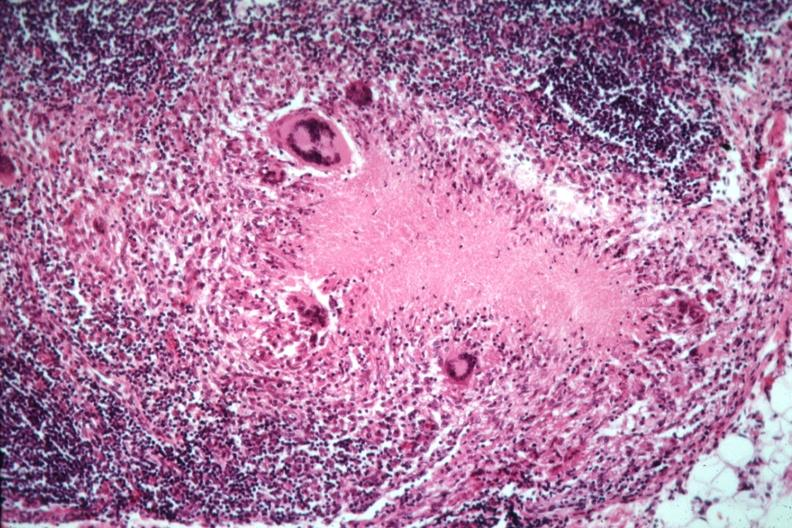s lymph node present?
Answer the question using a single word or phrase. Yes 